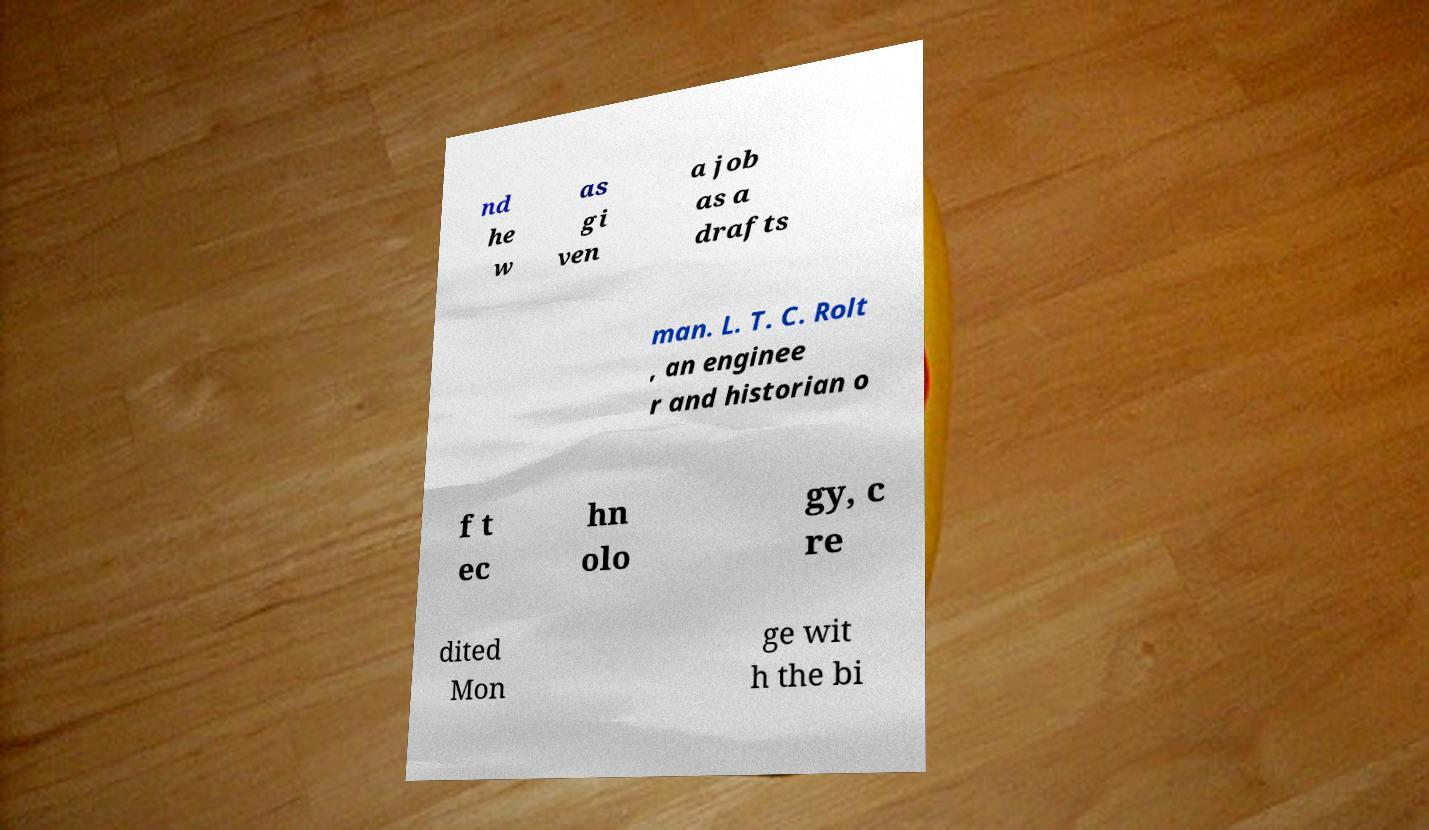There's text embedded in this image that I need extracted. Can you transcribe it verbatim? nd he w as gi ven a job as a drafts man. L. T. C. Rolt , an enginee r and historian o f t ec hn olo gy, c re dited Mon ge wit h the bi 